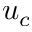<formula> <loc_0><loc_0><loc_500><loc_500>u _ { c }</formula> 